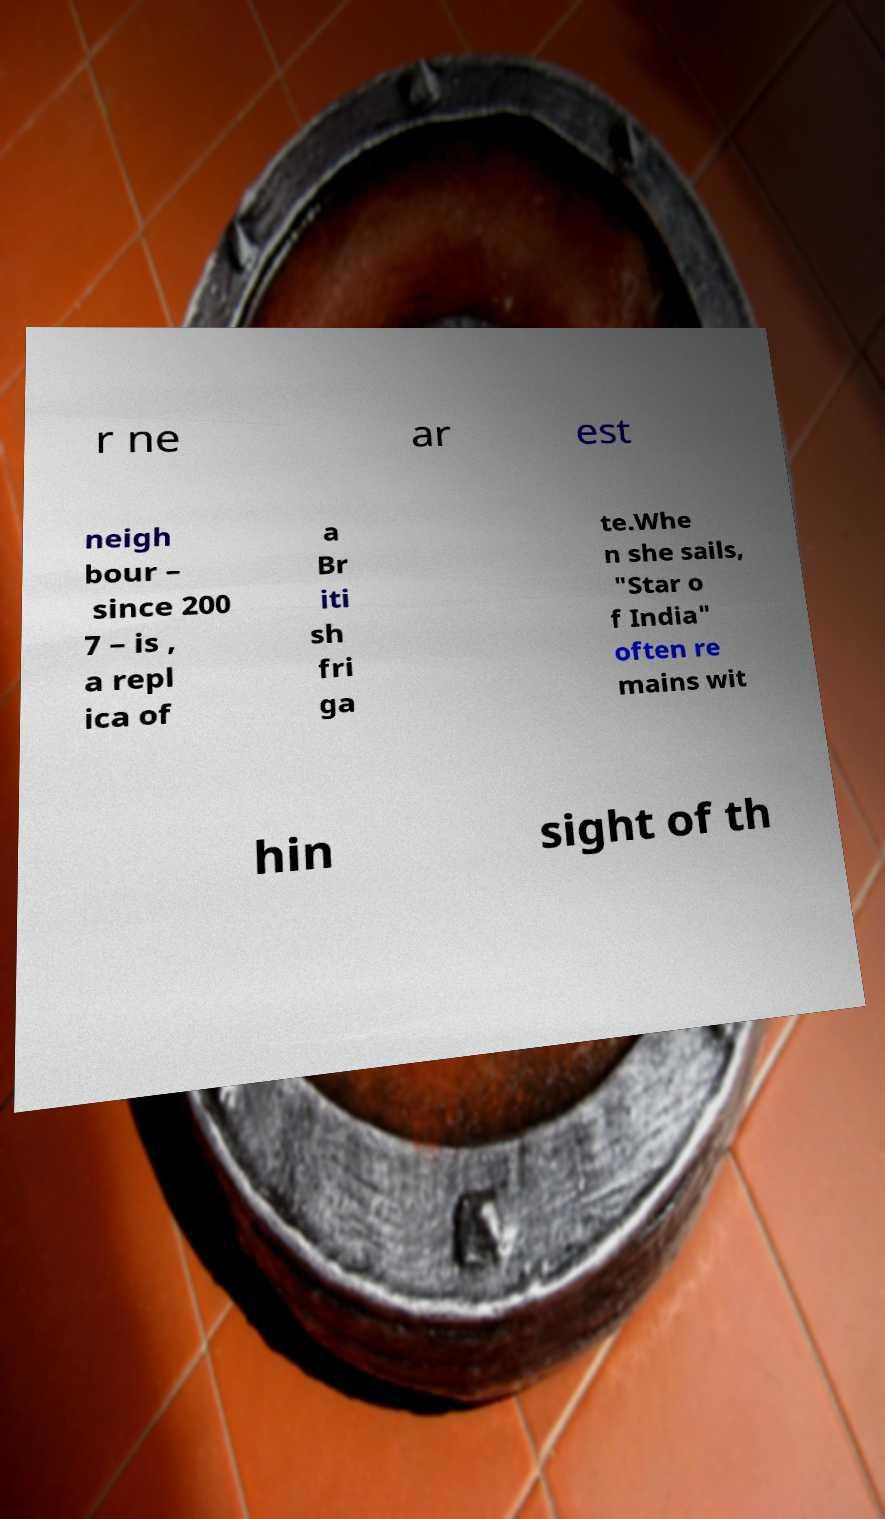For documentation purposes, I need the text within this image transcribed. Could you provide that? r ne ar est neigh bour – since 200 7 – is , a repl ica of a Br iti sh fri ga te.Whe n she sails, "Star o f India" often re mains wit hin sight of th 